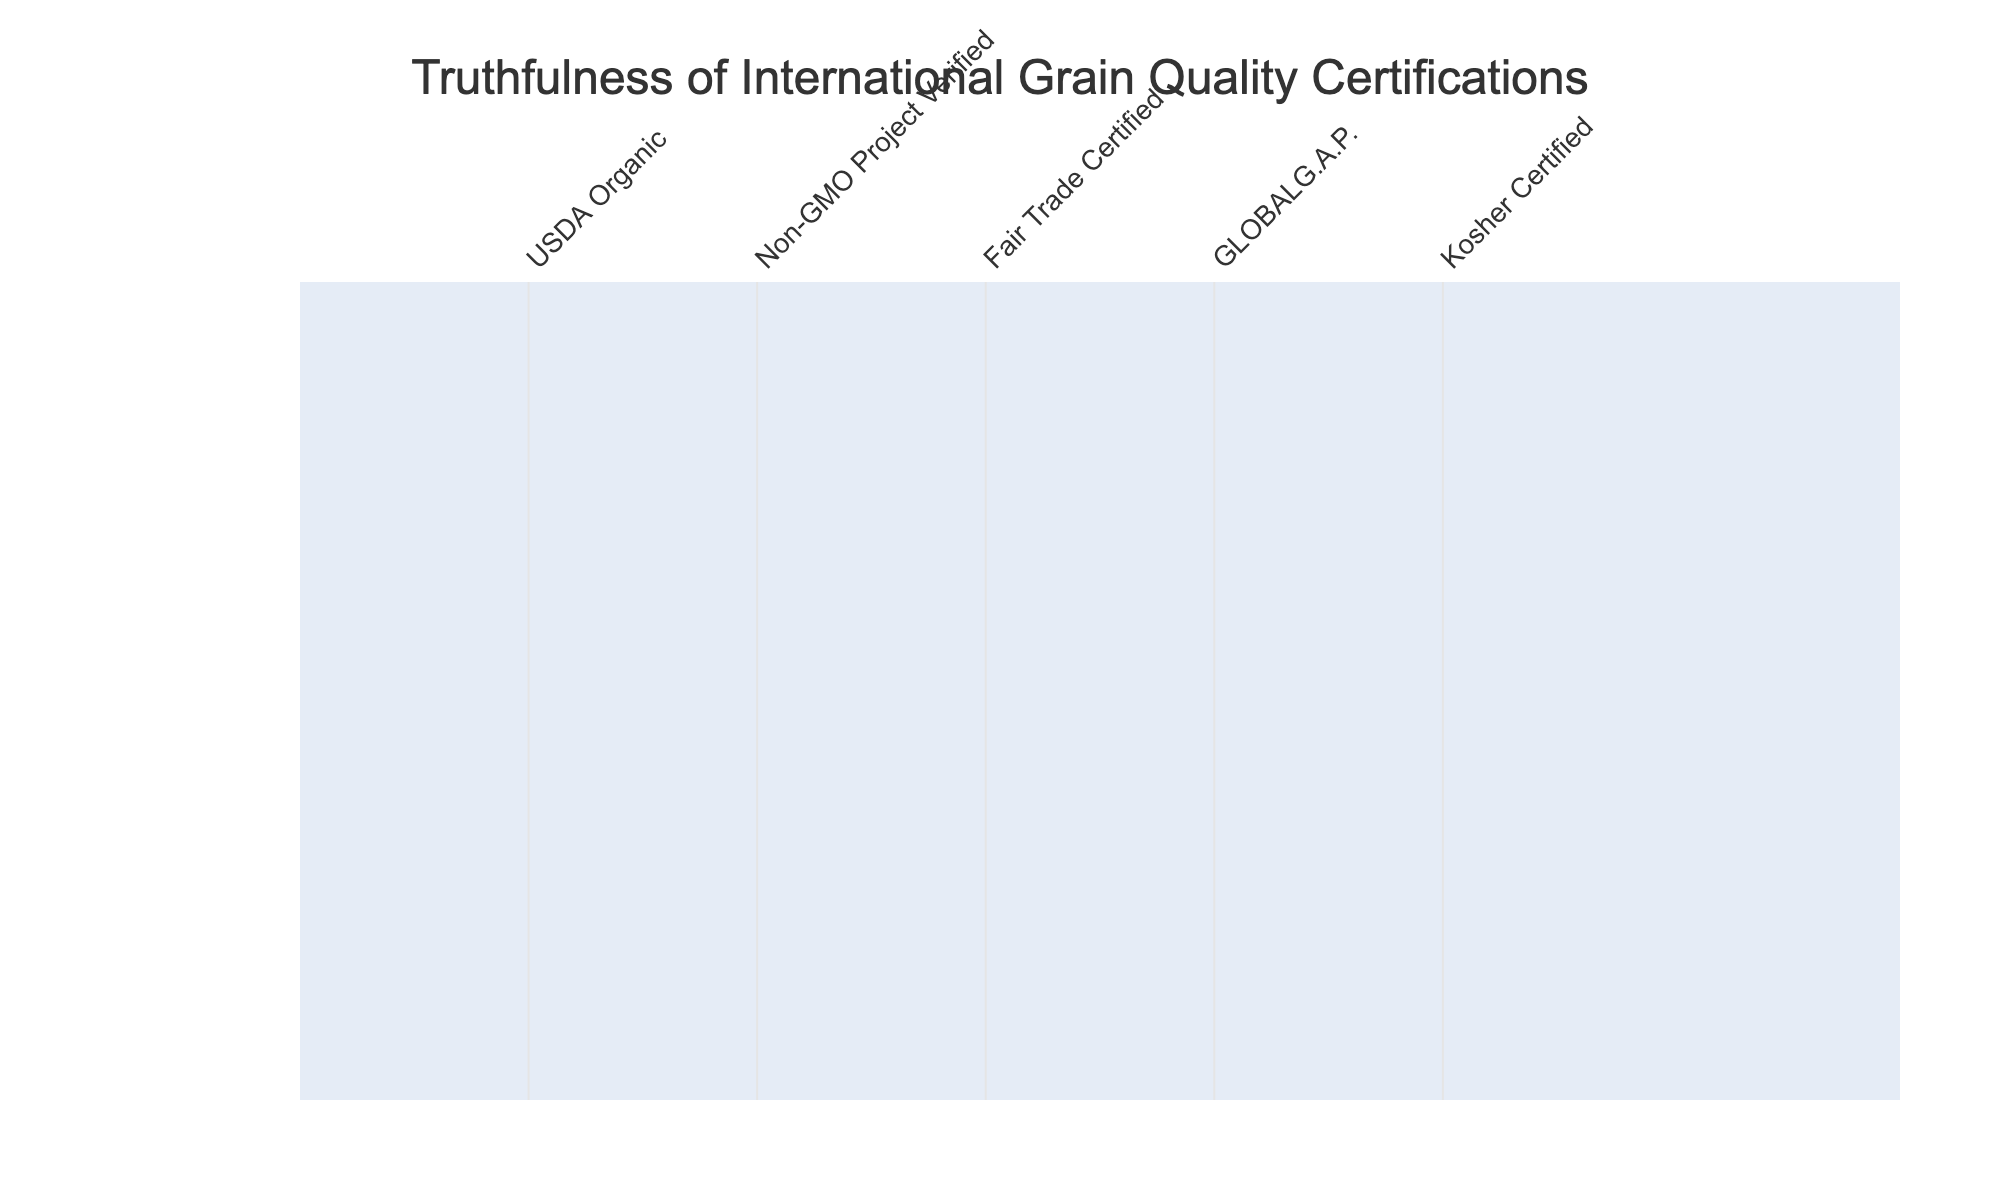What grain exporter is Fair Trade Certified? By inspecting the row of each exporter, I note that ADM, Louis Dreyfus, and The Andersons are the ones with "True" listed under Fair Trade Certified.
Answer: ADM, Louis Dreyfus How many certifications does Cargill have that are marked as True? Cargill has five certifications: USDA Organic, Non-GMO Project Verified, GLOBALG.A.P., and Kosher Certified marked as True. Thus, the total count is 4.
Answer: 4 Is Bunge USDA Organic Certified? Looking at Bunge's row, it is marked as "False" for USDA Organic Certification.
Answer: No Which exporter has the least certifications marked as True, and how many do they have? The Andersons has two certifications marked as True (Fair Trade Certified and GLOBALG.A.P.), which is the least among all exporters.
Answer: The Andersons, 2 How many exporters are Non-GMO Project Verified but not Kosher Certified? Gavilon and COFCO International are Non-GMO Project Verified but are not Kosher Certified. Hence, the total count is 2.
Answer: 2 Is it true that all exporters listed have at least one certification marked as True? When verifying each row, I find that there is no case where all the certifications are False. Thus, the statement is True.
Answer: Yes What is the total number of exporters certified by GLOBALG.A.P.? By examining the table, Cargill, Bunge, Louis Dreyfus, Gavilon, and Glencore Agriculture are certified by GLOBALG.A.P., resulting in a total of 5 exporters.
Answer: 5 Which certification does CHS Inc. lack? In the row for CHS Inc., it is marked as False for Fair Trade Certified, meaning this certification is the one they lack.
Answer: Fair Trade Certified How many certifications does the majority of exporters have that are marked as True? Counting the number of certifications marked as True, USDA Organic has 6, Non-GMO Project Verified has 6, Fair Trade Certified has 4, GLOBALG.A.P. has 5, and Kosher Certified has 5. Thus, USDA Organic and Non-GMO Project Verified are the majority with 6 each.
Answer: 6 